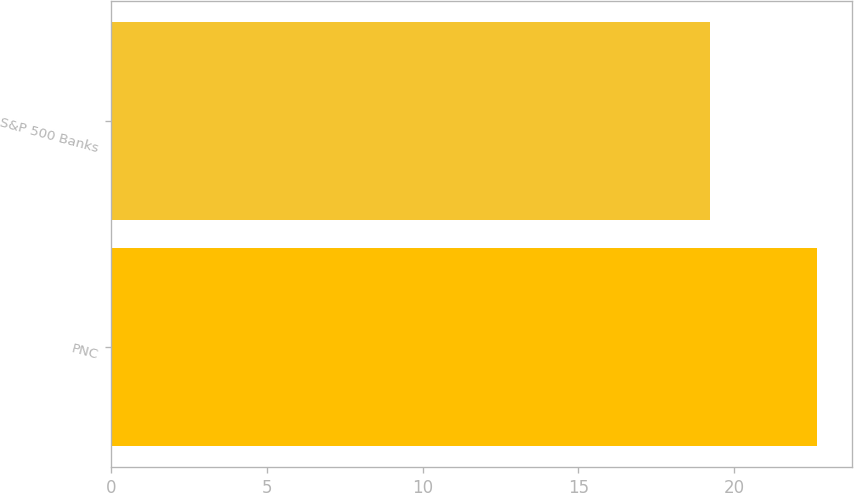<chart> <loc_0><loc_0><loc_500><loc_500><bar_chart><fcel>PNC<fcel>S&P 500 Banks<nl><fcel>22.67<fcel>19.22<nl></chart> 